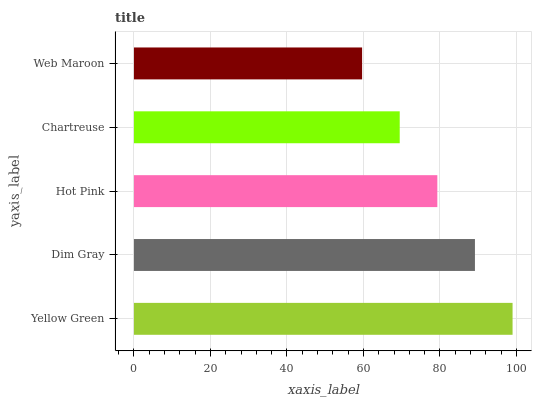Is Web Maroon the minimum?
Answer yes or no. Yes. Is Yellow Green the maximum?
Answer yes or no. Yes. Is Dim Gray the minimum?
Answer yes or no. No. Is Dim Gray the maximum?
Answer yes or no. No. Is Yellow Green greater than Dim Gray?
Answer yes or no. Yes. Is Dim Gray less than Yellow Green?
Answer yes or no. Yes. Is Dim Gray greater than Yellow Green?
Answer yes or no. No. Is Yellow Green less than Dim Gray?
Answer yes or no. No. Is Hot Pink the high median?
Answer yes or no. Yes. Is Hot Pink the low median?
Answer yes or no. Yes. Is Chartreuse the high median?
Answer yes or no. No. Is Yellow Green the low median?
Answer yes or no. No. 